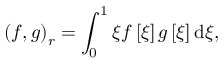<formula> <loc_0><loc_0><loc_500><loc_500>\left ( f , g \right ) _ { r } = \int _ { 0 } ^ { 1 } \xi f \left [ \xi \right ] g \left [ \xi \right ] d \xi ,</formula> 